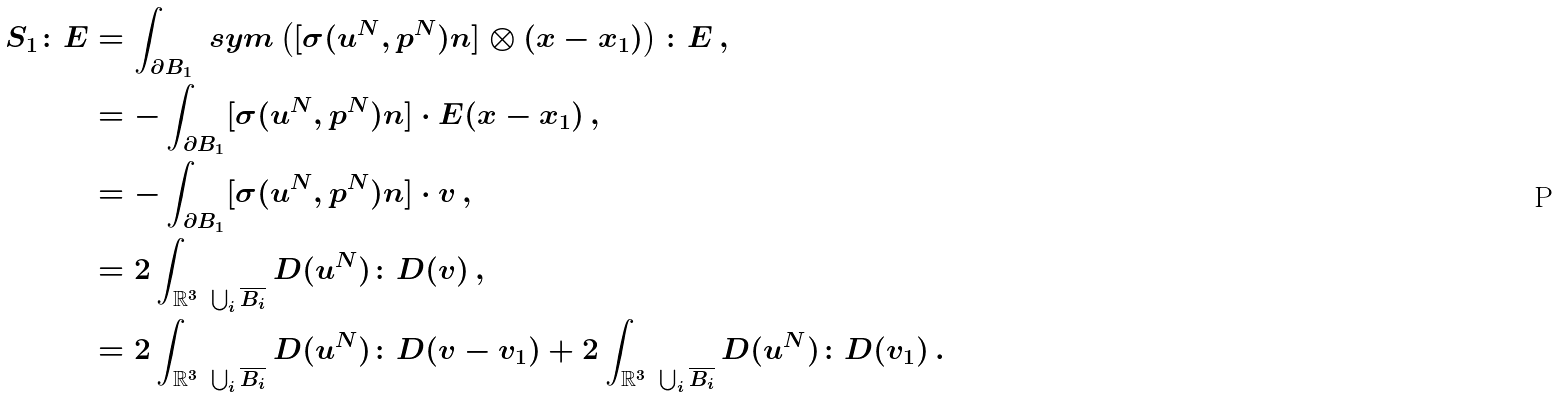<formula> <loc_0><loc_0><loc_500><loc_500>S _ { 1 } \colon E & = \int _ { \partial B _ { 1 } } \ s y m \left ( [ \sigma ( u ^ { N } , p ^ { N } ) n ] \otimes ( x - x _ { 1 } ) \right ) \colon E \, , \\ & = - \int _ { \partial B _ { 1 } } [ \sigma ( u ^ { N } , p ^ { N } ) n ] \cdot E ( x - x _ { 1 } ) \, , \\ & = - \int _ { \partial B _ { 1 } } [ \sigma ( u ^ { N } , p ^ { N } ) n ] \cdot v \, , \\ & = 2 \int _ { \mathbb { R } ^ { 3 } \ \bigcup _ { i } \overline { B _ { i } } } D ( u ^ { N } ) \colon D ( v ) \, , \\ & = 2 \int _ { \mathbb { R } ^ { 3 } \ \bigcup _ { i } \overline { B _ { i } } } D ( u ^ { N } ) \colon D ( v - v _ { 1 } ) + 2 \int _ { \mathbb { R } ^ { 3 } \ \bigcup _ { i } \overline { B _ { i } } } D ( u ^ { N } ) \colon D ( v _ { 1 } ) \, .</formula> 